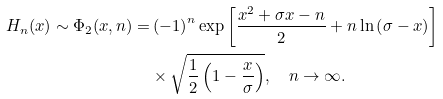Convert formula to latex. <formula><loc_0><loc_0><loc_500><loc_500>H _ { n } ( x ) \sim \Phi _ { 2 } ( x , n ) = & \left ( - 1 \right ) ^ { n } \exp \left [ \frac { x ^ { 2 } + \sigma x - n } { 2 } + n \ln \left ( \sigma - x \right ) \right ] \\ & \times \sqrt { \frac { 1 } { 2 } \left ( 1 - \frac { x } { \sigma } \right ) } , \quad n \rightarrow \infty .</formula> 